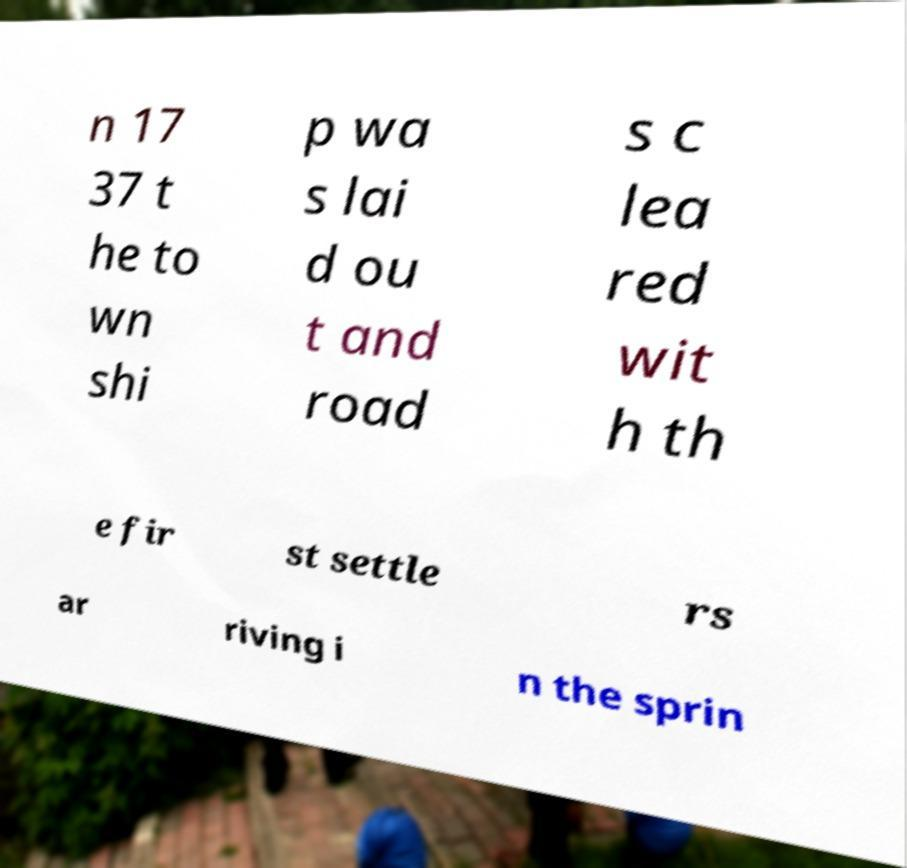There's text embedded in this image that I need extracted. Can you transcribe it verbatim? n 17 37 t he to wn shi p wa s lai d ou t and road s c lea red wit h th e fir st settle rs ar riving i n the sprin 